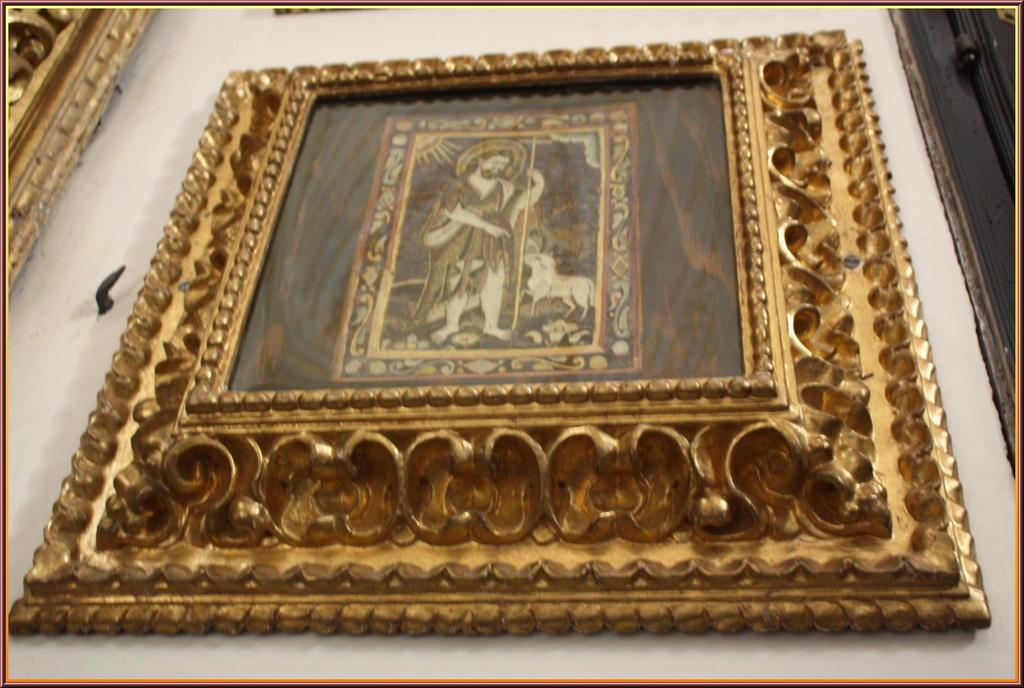What type of frame is visible in the image? There is a gold frame in the image. Where is the gold frame located? The gold frame is hanging on a wall. What type of humor can be seen in the image? There is no humor present in the image; it features a gold frame hanging on a wall. What time of day is depicted in the image? The image does not depict a specific time of day, as it only shows a gold frame hanging on a wall. 